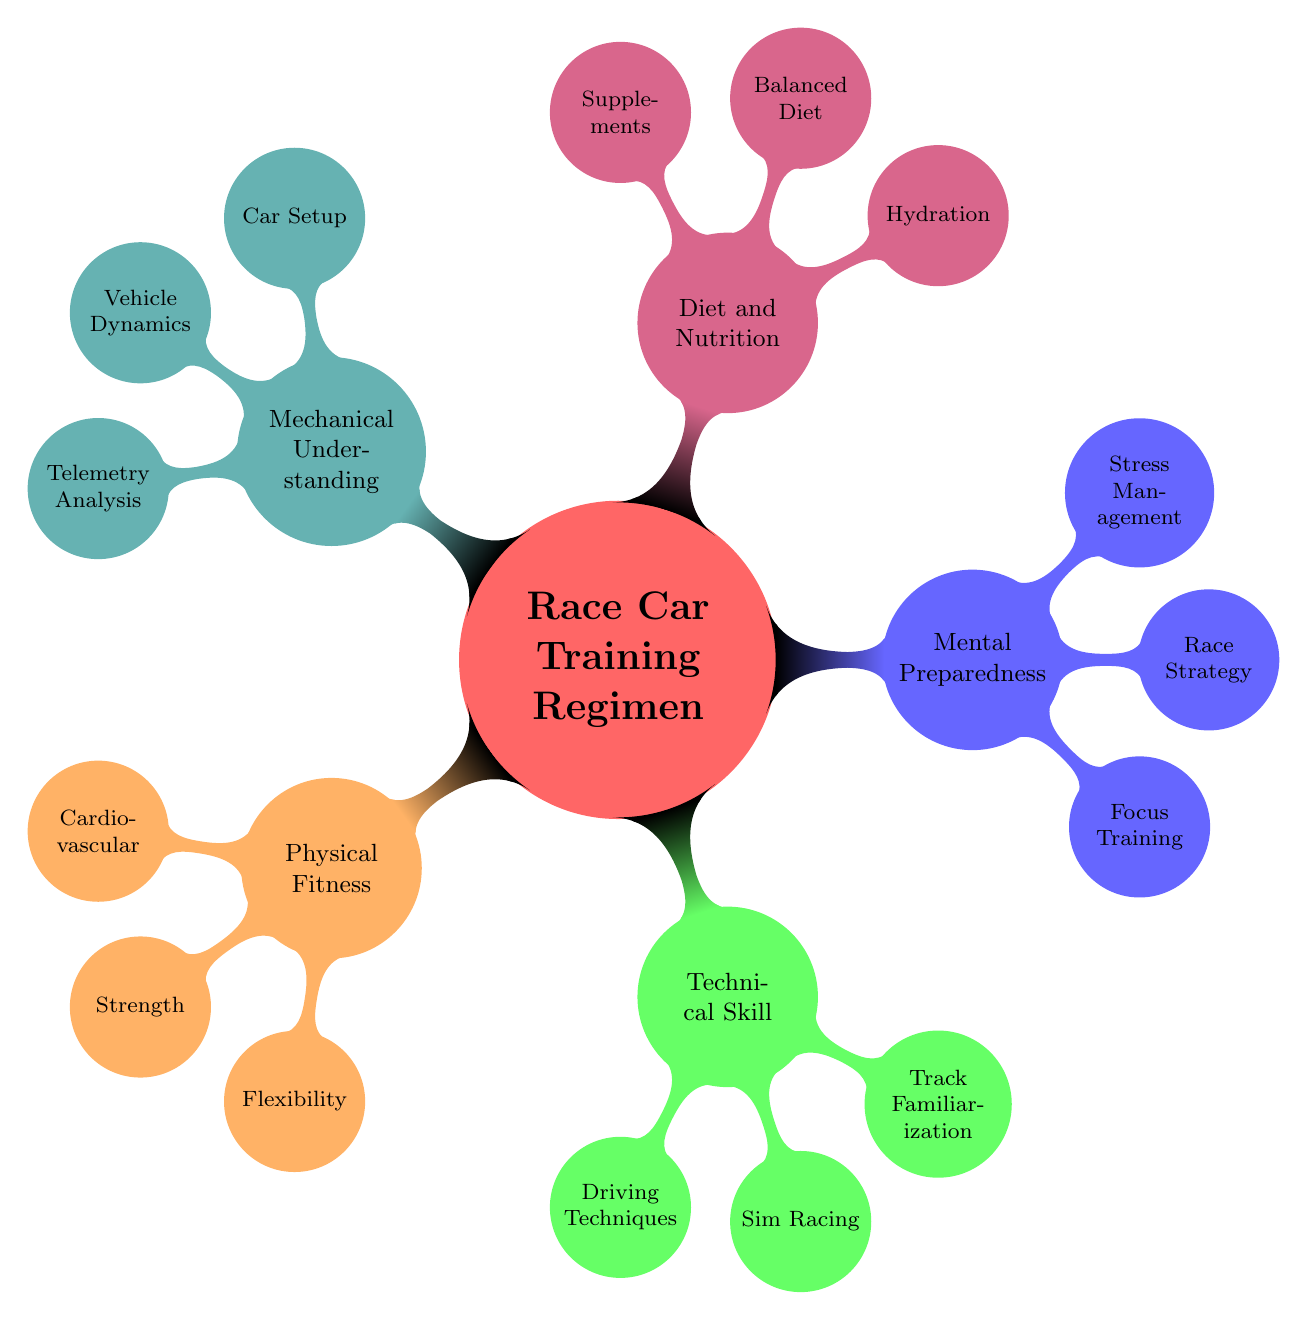What are the main categories of race car training? The main categories are listed as nodes from the central concept "Race Car Training Regimen". These categories include Physical Fitness, Technical Skill Development, Mental Preparedness, Diet and Nutrition, and Mechanical Understanding.
Answer: Physical Fitness, Technical Skill Development, Mental Preparedness, Diet and Nutrition, Mechanical Understanding How many sub-nodes are under Technical Skill Development? By observing the main category of Technical Skill Development, there are three sub-nodes: Driving Techniques, Sim Racing, and Track Familiarization. Counting these, we see that there are a total of 3 sub-nodes.
Answer: 3 What is a type of exercise mentioned under Physical Fitness? Under Physical Fitness, the sub-categories include Cardiovascular Training, Strength Training, and Flexibility. Each of these has specific examples like Running under Cardiovascular Training. Thus, Running serves as a specific exercise example.
Answer: Running Which category includes Stress Management techniques? By looking at the categories, Stress Management is found under Mental Preparedness, where it is mentioned along with Focus Training and Race Strategy. This shows that it is directly related to mental aspects of training.
Answer: Mental Preparedness What are the elements of Mechanical Understanding? In the category of Mechanical Understanding, there are three elements listed: Car Setup Knowledge, Vehicle Dynamics, and Telemetry Analysis. Each of these elements contributes to understanding the technical details of the vehicle.
Answer: Car Setup Knowledge, Vehicle Dynamics, Telemetry Analysis How are the categories organized in the diagram? The categories are organized around the central concept of Race Car Training Regimen, growing outwards in a radial manner. Each category is a branch, leading to various sub-nodes that provide further detail. This structure allows for a clear visual hierarchy of information.
Answer: Radial hierarchy What is one type of driving technique listed? The diagram under Technical Skill Development specifies Heel-Toe Shifting and Trail Braking as the driving techniques, indicating that these are crucial skills for performance driving. Either of these can be mentioned as a valid answer.
Answer: Heel-Toe Shifting What are two components of Diet and Nutrition? Under Diet and Nutrition, there are three components listed: Hydration, Balanced Diet, and Supplements. The question asks for two, which can be selected from these options, for example, Hydration and Balanced Diet.
Answer: Hydration, Balanced Diet 